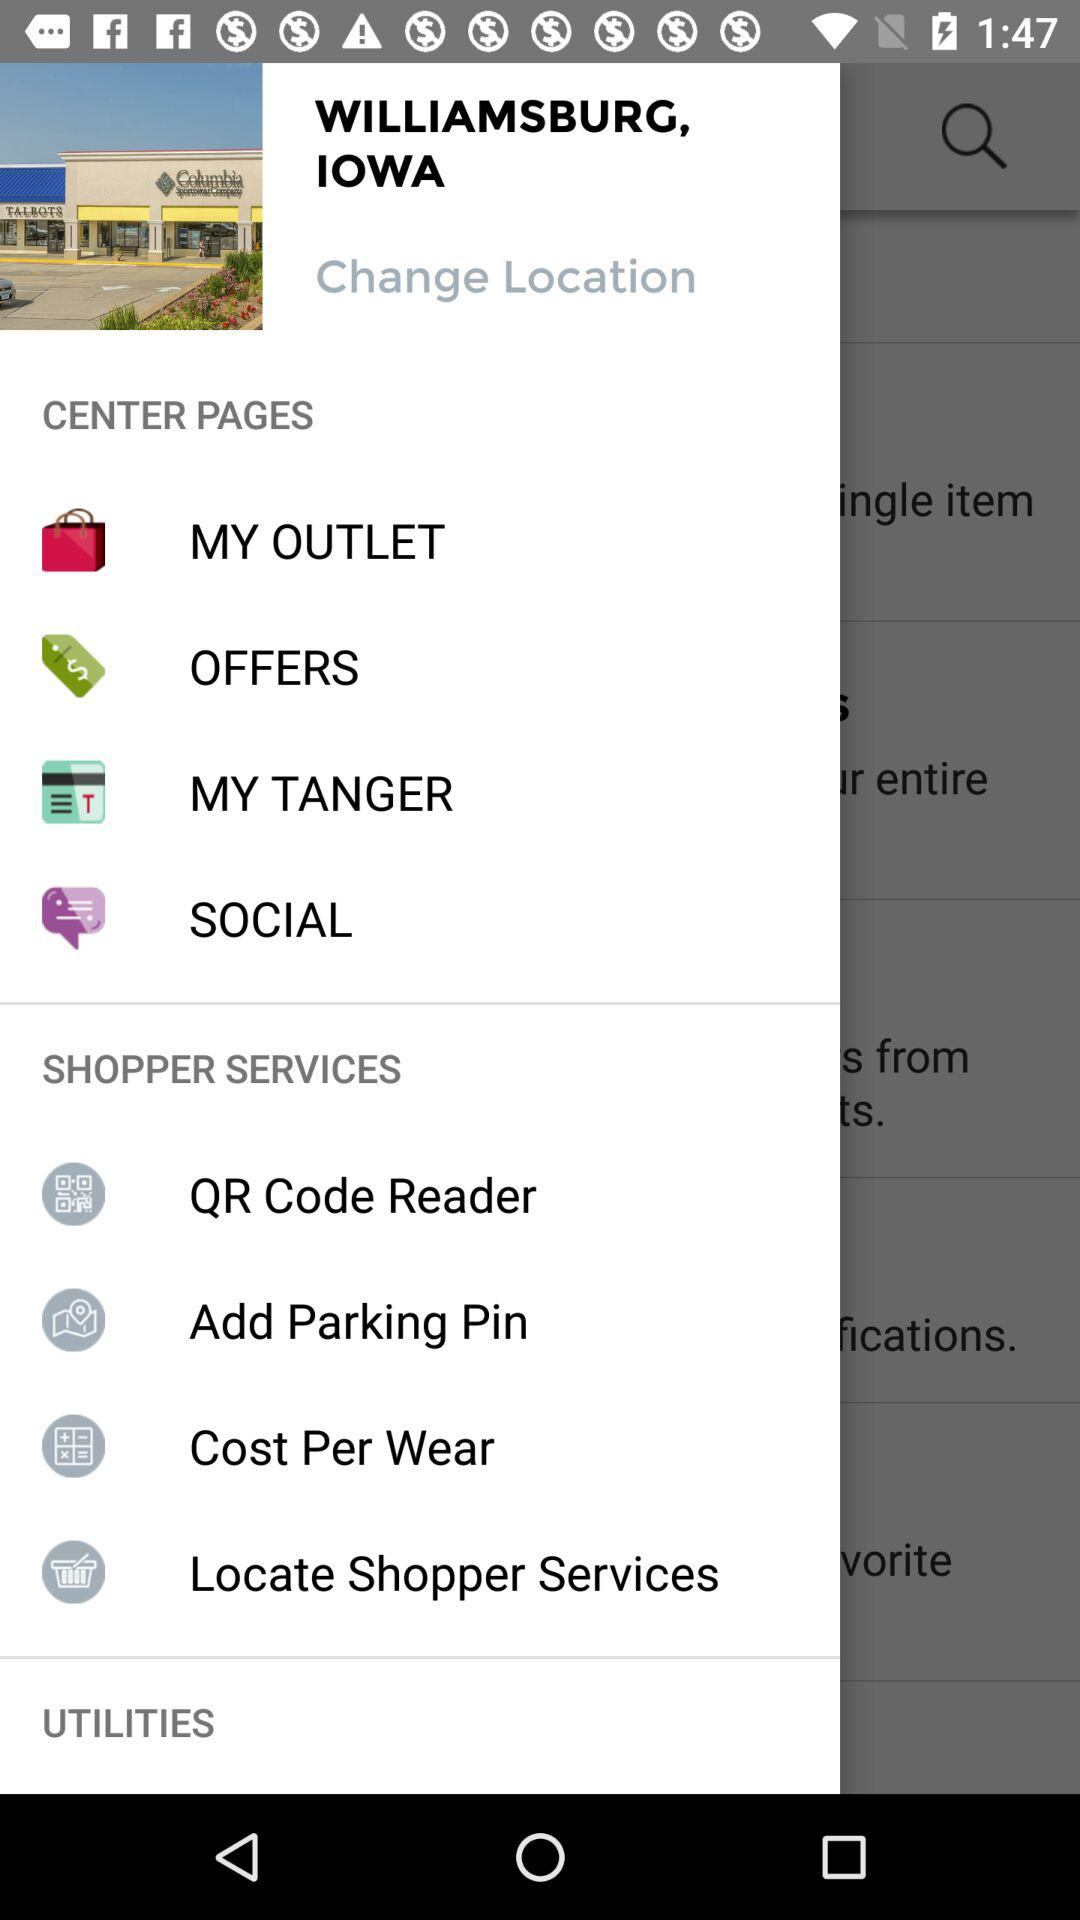What's the current location? The current location is Williamsburg, Iowa. 